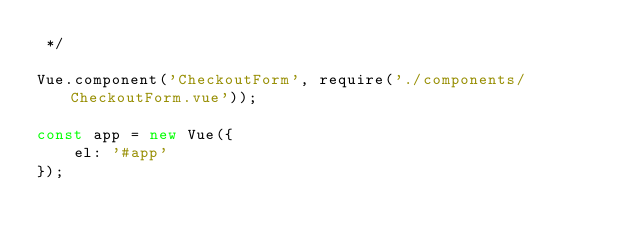Convert code to text. <code><loc_0><loc_0><loc_500><loc_500><_JavaScript_> */

Vue.component('CheckoutForm', require('./components/CheckoutForm.vue'));

const app = new Vue({
    el: '#app'
});
</code> 